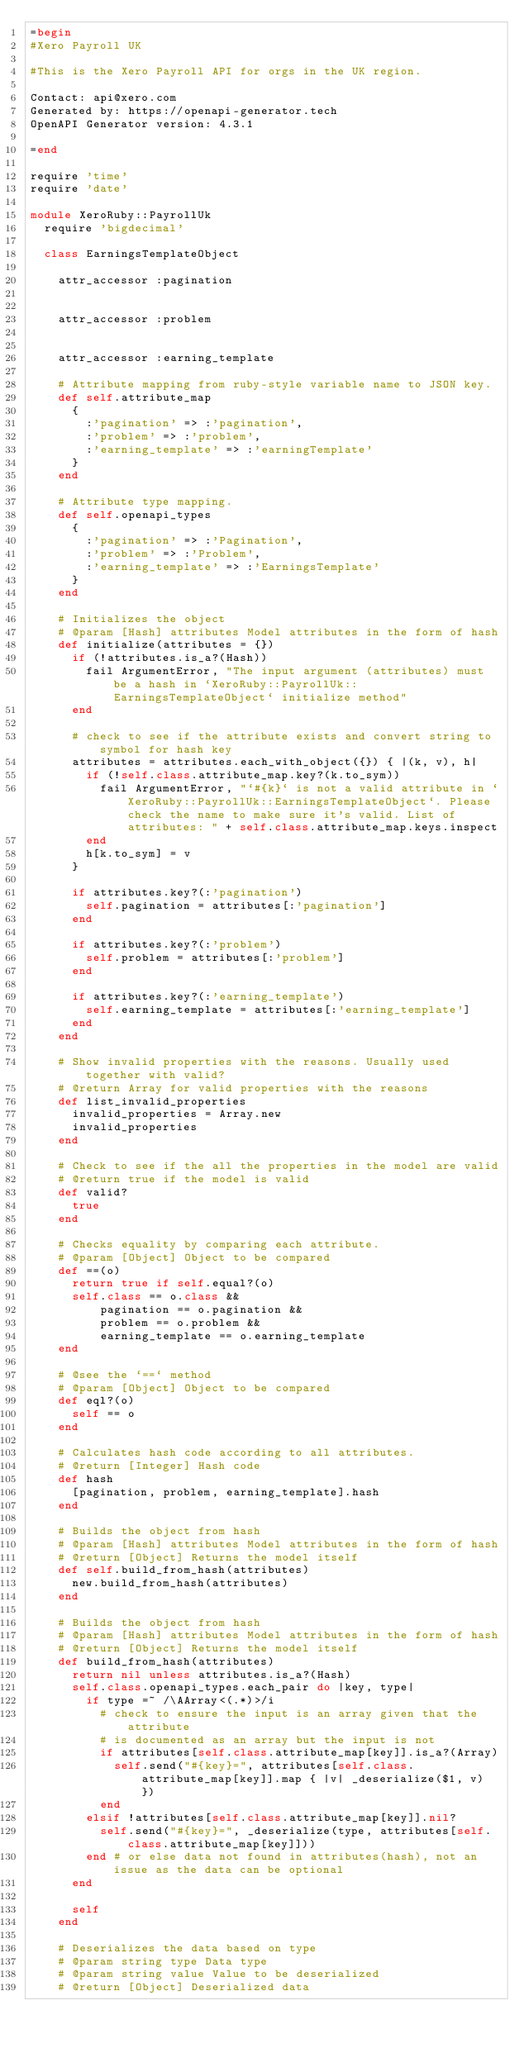Convert code to text. <code><loc_0><loc_0><loc_500><loc_500><_Ruby_>=begin
#Xero Payroll UK

#This is the Xero Payroll API for orgs in the UK region.

Contact: api@xero.com
Generated by: https://openapi-generator.tech
OpenAPI Generator version: 4.3.1

=end

require 'time'
require 'date'

module XeroRuby::PayrollUk
  require 'bigdecimal'

  class EarningsTemplateObject

    attr_accessor :pagination
    

    attr_accessor :problem
    

    attr_accessor :earning_template
    
    # Attribute mapping from ruby-style variable name to JSON key.
    def self.attribute_map
      {
        :'pagination' => :'pagination',
        :'problem' => :'problem',
        :'earning_template' => :'earningTemplate'
      }
    end

    # Attribute type mapping.
    def self.openapi_types
      {
        :'pagination' => :'Pagination',
        :'problem' => :'Problem',
        :'earning_template' => :'EarningsTemplate'
      }
    end

    # Initializes the object
    # @param [Hash] attributes Model attributes in the form of hash
    def initialize(attributes = {})
      if (!attributes.is_a?(Hash))
        fail ArgumentError, "The input argument (attributes) must be a hash in `XeroRuby::PayrollUk::EarningsTemplateObject` initialize method"
      end

      # check to see if the attribute exists and convert string to symbol for hash key
      attributes = attributes.each_with_object({}) { |(k, v), h|
        if (!self.class.attribute_map.key?(k.to_sym))
          fail ArgumentError, "`#{k}` is not a valid attribute in `XeroRuby::PayrollUk::EarningsTemplateObject`. Please check the name to make sure it's valid. List of attributes: " + self.class.attribute_map.keys.inspect
        end
        h[k.to_sym] = v
      }

      if attributes.key?(:'pagination')
        self.pagination = attributes[:'pagination']
      end

      if attributes.key?(:'problem')
        self.problem = attributes[:'problem']
      end

      if attributes.key?(:'earning_template')
        self.earning_template = attributes[:'earning_template']
      end
    end

    # Show invalid properties with the reasons. Usually used together with valid?
    # @return Array for valid properties with the reasons
    def list_invalid_properties
      invalid_properties = Array.new
      invalid_properties
    end

    # Check to see if the all the properties in the model are valid
    # @return true if the model is valid
    def valid?
      true
    end

    # Checks equality by comparing each attribute.
    # @param [Object] Object to be compared
    def ==(o)
      return true if self.equal?(o)
      self.class == o.class &&
          pagination == o.pagination &&
          problem == o.problem &&
          earning_template == o.earning_template
    end

    # @see the `==` method
    # @param [Object] Object to be compared
    def eql?(o)
      self == o
    end

    # Calculates hash code according to all attributes.
    # @return [Integer] Hash code
    def hash
      [pagination, problem, earning_template].hash
    end

    # Builds the object from hash
    # @param [Hash] attributes Model attributes in the form of hash
    # @return [Object] Returns the model itself
    def self.build_from_hash(attributes)
      new.build_from_hash(attributes)
    end

    # Builds the object from hash
    # @param [Hash] attributes Model attributes in the form of hash
    # @return [Object] Returns the model itself
    def build_from_hash(attributes)
      return nil unless attributes.is_a?(Hash)
      self.class.openapi_types.each_pair do |key, type|
        if type =~ /\AArray<(.*)>/i
          # check to ensure the input is an array given that the attribute
          # is documented as an array but the input is not
          if attributes[self.class.attribute_map[key]].is_a?(Array)
            self.send("#{key}=", attributes[self.class.attribute_map[key]].map { |v| _deserialize($1, v) })
          end
        elsif !attributes[self.class.attribute_map[key]].nil?
          self.send("#{key}=", _deserialize(type, attributes[self.class.attribute_map[key]]))
        end # or else data not found in attributes(hash), not an issue as the data can be optional
      end

      self
    end

    # Deserializes the data based on type
    # @param string type Data type
    # @param string value Value to be deserialized
    # @return [Object] Deserialized data</code> 